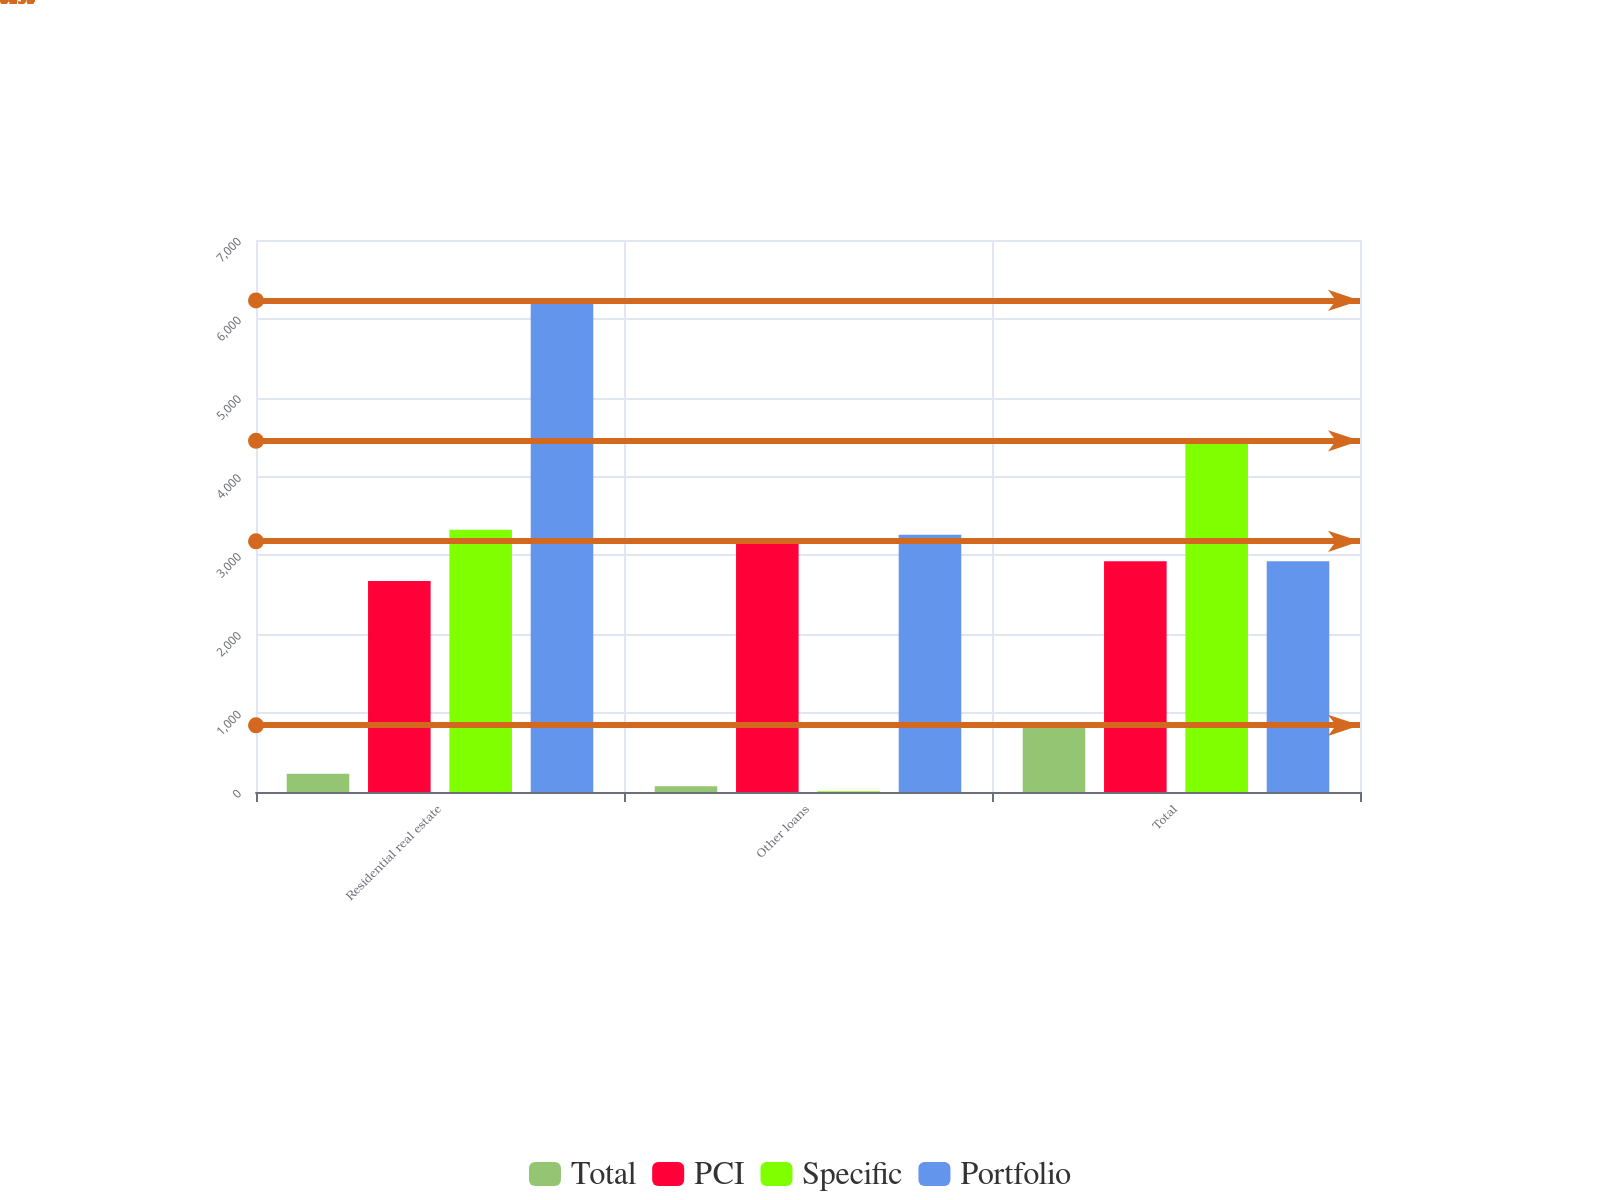Convert chart to OTSL. <chart><loc_0><loc_0><loc_500><loc_500><stacked_bar_chart><ecel><fcel>Residential real estate<fcel>Other loans<fcel>Total<nl><fcel>Total<fcel>231<fcel>74<fcel>845<nl><fcel>PCI<fcel>2676<fcel>3179<fcel>2927.5<nl><fcel>Specific<fcel>3327<fcel>10<fcel>4453<nl><fcel>Portfolio<fcel>6234<fcel>3263<fcel>2927.5<nl></chart> 